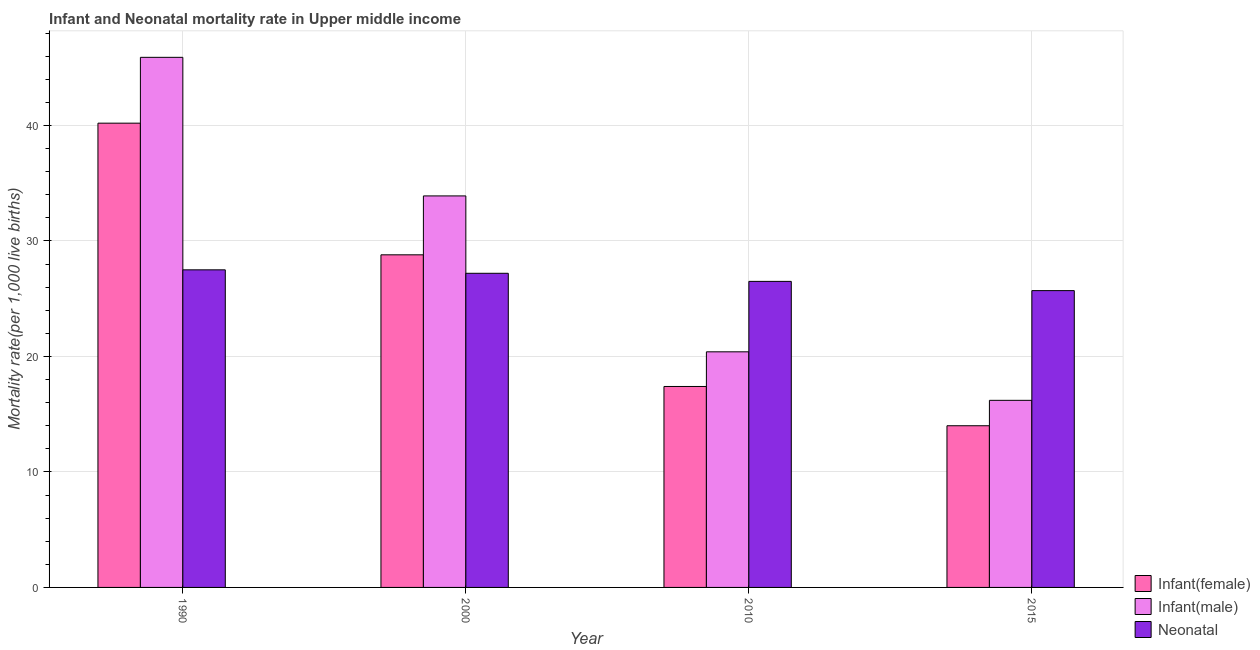How many groups of bars are there?
Your answer should be very brief. 4. Are the number of bars per tick equal to the number of legend labels?
Give a very brief answer. Yes. How many bars are there on the 3rd tick from the right?
Ensure brevity in your answer.  3. What is the label of the 2nd group of bars from the left?
Your response must be concise. 2000. In how many cases, is the number of bars for a given year not equal to the number of legend labels?
Make the answer very short. 0. What is the infant mortality rate(male) in 2000?
Provide a short and direct response. 33.9. Across all years, what is the maximum infant mortality rate(male)?
Keep it short and to the point. 45.9. Across all years, what is the minimum infant mortality rate(male)?
Provide a succinct answer. 16.2. In which year was the infant mortality rate(male) maximum?
Ensure brevity in your answer.  1990. In which year was the infant mortality rate(male) minimum?
Give a very brief answer. 2015. What is the total infant mortality rate(male) in the graph?
Your answer should be very brief. 116.4. What is the difference between the neonatal mortality rate in 2000 and the infant mortality rate(male) in 1990?
Make the answer very short. -0.3. What is the average infant mortality rate(female) per year?
Make the answer very short. 25.1. What is the ratio of the infant mortality rate(male) in 1990 to that in 2000?
Ensure brevity in your answer.  1.35. Is the difference between the infant mortality rate(male) in 1990 and 2010 greater than the difference between the neonatal mortality rate in 1990 and 2010?
Your answer should be very brief. No. What is the difference between the highest and the second highest infant mortality rate(female)?
Give a very brief answer. 11.4. What is the difference between the highest and the lowest infant mortality rate(female)?
Ensure brevity in your answer.  26.2. In how many years, is the infant mortality rate(male) greater than the average infant mortality rate(male) taken over all years?
Ensure brevity in your answer.  2. What does the 3rd bar from the left in 2015 represents?
Keep it short and to the point. Neonatal . What does the 3rd bar from the right in 1990 represents?
Offer a terse response. Infant(female). Is it the case that in every year, the sum of the infant mortality rate(female) and infant mortality rate(male) is greater than the neonatal mortality rate?
Your answer should be very brief. Yes. How many bars are there?
Your answer should be compact. 12. How many years are there in the graph?
Offer a very short reply. 4. What is the difference between two consecutive major ticks on the Y-axis?
Offer a very short reply. 10. Are the values on the major ticks of Y-axis written in scientific E-notation?
Ensure brevity in your answer.  No. Does the graph contain any zero values?
Your answer should be compact. No. Does the graph contain grids?
Your answer should be very brief. Yes. How are the legend labels stacked?
Offer a terse response. Vertical. What is the title of the graph?
Your response must be concise. Infant and Neonatal mortality rate in Upper middle income. Does "Ores and metals" appear as one of the legend labels in the graph?
Make the answer very short. No. What is the label or title of the Y-axis?
Your answer should be compact. Mortality rate(per 1,0 live births). What is the Mortality rate(per 1,000 live births) of Infant(female) in 1990?
Offer a terse response. 40.2. What is the Mortality rate(per 1,000 live births) in Infant(male) in 1990?
Make the answer very short. 45.9. What is the Mortality rate(per 1,000 live births) of Neonatal  in 1990?
Provide a short and direct response. 27.5. What is the Mortality rate(per 1,000 live births) in Infant(female) in 2000?
Your response must be concise. 28.8. What is the Mortality rate(per 1,000 live births) of Infant(male) in 2000?
Ensure brevity in your answer.  33.9. What is the Mortality rate(per 1,000 live births) of Neonatal  in 2000?
Offer a very short reply. 27.2. What is the Mortality rate(per 1,000 live births) in Infant(female) in 2010?
Your response must be concise. 17.4. What is the Mortality rate(per 1,000 live births) of Infant(male) in 2010?
Make the answer very short. 20.4. What is the Mortality rate(per 1,000 live births) in Neonatal  in 2010?
Keep it short and to the point. 26.5. What is the Mortality rate(per 1,000 live births) in Infant(female) in 2015?
Your answer should be compact. 14. What is the Mortality rate(per 1,000 live births) of Neonatal  in 2015?
Offer a very short reply. 25.7. Across all years, what is the maximum Mortality rate(per 1,000 live births) of Infant(female)?
Offer a terse response. 40.2. Across all years, what is the maximum Mortality rate(per 1,000 live births) in Infant(male)?
Your answer should be compact. 45.9. Across all years, what is the maximum Mortality rate(per 1,000 live births) in Neonatal ?
Offer a terse response. 27.5. Across all years, what is the minimum Mortality rate(per 1,000 live births) of Neonatal ?
Your answer should be compact. 25.7. What is the total Mortality rate(per 1,000 live births) in Infant(female) in the graph?
Your answer should be compact. 100.4. What is the total Mortality rate(per 1,000 live births) in Infant(male) in the graph?
Give a very brief answer. 116.4. What is the total Mortality rate(per 1,000 live births) in Neonatal  in the graph?
Ensure brevity in your answer.  106.9. What is the difference between the Mortality rate(per 1,000 live births) in Infant(female) in 1990 and that in 2010?
Your answer should be very brief. 22.8. What is the difference between the Mortality rate(per 1,000 live births) of Infant(male) in 1990 and that in 2010?
Ensure brevity in your answer.  25.5. What is the difference between the Mortality rate(per 1,000 live births) of Infant(female) in 1990 and that in 2015?
Offer a terse response. 26.2. What is the difference between the Mortality rate(per 1,000 live births) in Infant(male) in 1990 and that in 2015?
Give a very brief answer. 29.7. What is the difference between the Mortality rate(per 1,000 live births) in Infant(male) in 2000 and that in 2010?
Offer a terse response. 13.5. What is the difference between the Mortality rate(per 1,000 live births) of Neonatal  in 2000 and that in 2010?
Offer a very short reply. 0.7. What is the difference between the Mortality rate(per 1,000 live births) in Infant(female) in 2010 and that in 2015?
Offer a terse response. 3.4. What is the difference between the Mortality rate(per 1,000 live births) in Infant(male) in 1990 and the Mortality rate(per 1,000 live births) in Neonatal  in 2000?
Keep it short and to the point. 18.7. What is the difference between the Mortality rate(per 1,000 live births) of Infant(female) in 1990 and the Mortality rate(per 1,000 live births) of Infant(male) in 2010?
Your response must be concise. 19.8. What is the difference between the Mortality rate(per 1,000 live births) in Infant(female) in 1990 and the Mortality rate(per 1,000 live births) in Neonatal  in 2010?
Ensure brevity in your answer.  13.7. What is the difference between the Mortality rate(per 1,000 live births) in Infant(female) in 1990 and the Mortality rate(per 1,000 live births) in Infant(male) in 2015?
Provide a short and direct response. 24. What is the difference between the Mortality rate(per 1,000 live births) of Infant(male) in 1990 and the Mortality rate(per 1,000 live births) of Neonatal  in 2015?
Your answer should be compact. 20.2. What is the difference between the Mortality rate(per 1,000 live births) of Infant(female) in 2000 and the Mortality rate(per 1,000 live births) of Infant(male) in 2010?
Make the answer very short. 8.4. What is the difference between the Mortality rate(per 1,000 live births) in Infant(female) in 2000 and the Mortality rate(per 1,000 live births) in Infant(male) in 2015?
Make the answer very short. 12.6. What is the difference between the Mortality rate(per 1,000 live births) in Infant(male) in 2000 and the Mortality rate(per 1,000 live births) in Neonatal  in 2015?
Your answer should be very brief. 8.2. What is the difference between the Mortality rate(per 1,000 live births) in Infant(female) in 2010 and the Mortality rate(per 1,000 live births) in Neonatal  in 2015?
Offer a very short reply. -8.3. What is the difference between the Mortality rate(per 1,000 live births) of Infant(male) in 2010 and the Mortality rate(per 1,000 live births) of Neonatal  in 2015?
Offer a terse response. -5.3. What is the average Mortality rate(per 1,000 live births) of Infant(female) per year?
Offer a terse response. 25.1. What is the average Mortality rate(per 1,000 live births) of Infant(male) per year?
Your response must be concise. 29.1. What is the average Mortality rate(per 1,000 live births) in Neonatal  per year?
Give a very brief answer. 26.73. In the year 1990, what is the difference between the Mortality rate(per 1,000 live births) in Infant(female) and Mortality rate(per 1,000 live births) in Infant(male)?
Give a very brief answer. -5.7. In the year 1990, what is the difference between the Mortality rate(per 1,000 live births) of Infant(male) and Mortality rate(per 1,000 live births) of Neonatal ?
Your answer should be very brief. 18.4. In the year 2000, what is the difference between the Mortality rate(per 1,000 live births) in Infant(female) and Mortality rate(per 1,000 live births) in Infant(male)?
Keep it short and to the point. -5.1. In the year 2000, what is the difference between the Mortality rate(per 1,000 live births) of Infant(female) and Mortality rate(per 1,000 live births) of Neonatal ?
Your answer should be very brief. 1.6. In the year 2000, what is the difference between the Mortality rate(per 1,000 live births) in Infant(male) and Mortality rate(per 1,000 live births) in Neonatal ?
Provide a succinct answer. 6.7. In the year 2010, what is the difference between the Mortality rate(per 1,000 live births) of Infant(female) and Mortality rate(per 1,000 live births) of Infant(male)?
Keep it short and to the point. -3. In the year 2015, what is the difference between the Mortality rate(per 1,000 live births) in Infant(female) and Mortality rate(per 1,000 live births) in Infant(male)?
Offer a terse response. -2.2. In the year 2015, what is the difference between the Mortality rate(per 1,000 live births) in Infant(female) and Mortality rate(per 1,000 live births) in Neonatal ?
Make the answer very short. -11.7. What is the ratio of the Mortality rate(per 1,000 live births) of Infant(female) in 1990 to that in 2000?
Your answer should be very brief. 1.4. What is the ratio of the Mortality rate(per 1,000 live births) of Infant(male) in 1990 to that in 2000?
Keep it short and to the point. 1.35. What is the ratio of the Mortality rate(per 1,000 live births) of Infant(female) in 1990 to that in 2010?
Provide a succinct answer. 2.31. What is the ratio of the Mortality rate(per 1,000 live births) of Infant(male) in 1990 to that in 2010?
Your response must be concise. 2.25. What is the ratio of the Mortality rate(per 1,000 live births) in Neonatal  in 1990 to that in 2010?
Give a very brief answer. 1.04. What is the ratio of the Mortality rate(per 1,000 live births) in Infant(female) in 1990 to that in 2015?
Make the answer very short. 2.87. What is the ratio of the Mortality rate(per 1,000 live births) in Infant(male) in 1990 to that in 2015?
Offer a very short reply. 2.83. What is the ratio of the Mortality rate(per 1,000 live births) of Neonatal  in 1990 to that in 2015?
Ensure brevity in your answer.  1.07. What is the ratio of the Mortality rate(per 1,000 live births) of Infant(female) in 2000 to that in 2010?
Ensure brevity in your answer.  1.66. What is the ratio of the Mortality rate(per 1,000 live births) of Infant(male) in 2000 to that in 2010?
Provide a short and direct response. 1.66. What is the ratio of the Mortality rate(per 1,000 live births) in Neonatal  in 2000 to that in 2010?
Keep it short and to the point. 1.03. What is the ratio of the Mortality rate(per 1,000 live births) in Infant(female) in 2000 to that in 2015?
Your response must be concise. 2.06. What is the ratio of the Mortality rate(per 1,000 live births) in Infant(male) in 2000 to that in 2015?
Your answer should be very brief. 2.09. What is the ratio of the Mortality rate(per 1,000 live births) of Neonatal  in 2000 to that in 2015?
Your response must be concise. 1.06. What is the ratio of the Mortality rate(per 1,000 live births) of Infant(female) in 2010 to that in 2015?
Offer a terse response. 1.24. What is the ratio of the Mortality rate(per 1,000 live births) in Infant(male) in 2010 to that in 2015?
Your answer should be compact. 1.26. What is the ratio of the Mortality rate(per 1,000 live births) in Neonatal  in 2010 to that in 2015?
Provide a succinct answer. 1.03. What is the difference between the highest and the second highest Mortality rate(per 1,000 live births) in Infant(female)?
Your answer should be compact. 11.4. What is the difference between the highest and the lowest Mortality rate(per 1,000 live births) of Infant(female)?
Your answer should be compact. 26.2. What is the difference between the highest and the lowest Mortality rate(per 1,000 live births) of Infant(male)?
Offer a terse response. 29.7. What is the difference between the highest and the lowest Mortality rate(per 1,000 live births) in Neonatal ?
Your answer should be compact. 1.8. 